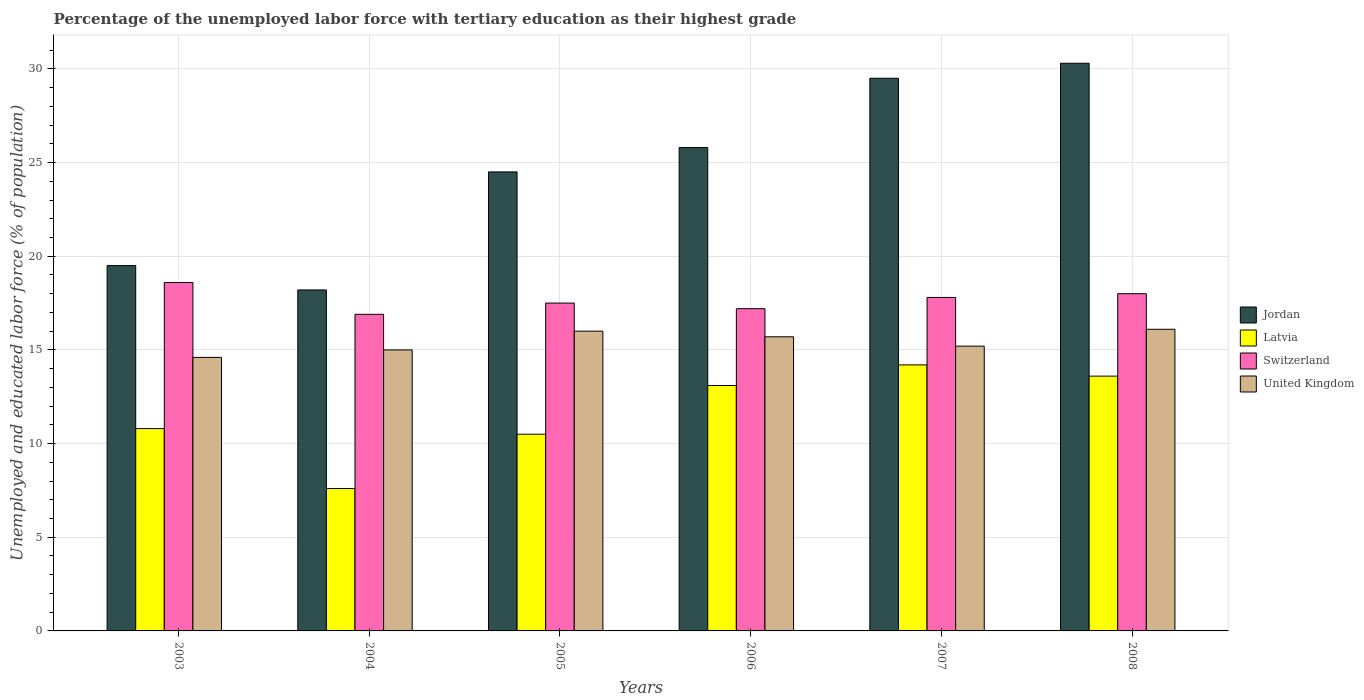How many groups of bars are there?
Offer a very short reply. 6. Are the number of bars per tick equal to the number of legend labels?
Your answer should be very brief. Yes. Are the number of bars on each tick of the X-axis equal?
Ensure brevity in your answer.  Yes. What is the percentage of the unemployed labor force with tertiary education in United Kingdom in 2006?
Your answer should be very brief. 15.7. Across all years, what is the maximum percentage of the unemployed labor force with tertiary education in Latvia?
Provide a short and direct response. 14.2. Across all years, what is the minimum percentage of the unemployed labor force with tertiary education in Switzerland?
Ensure brevity in your answer.  16.9. What is the total percentage of the unemployed labor force with tertiary education in Latvia in the graph?
Offer a terse response. 69.8. What is the difference between the percentage of the unemployed labor force with tertiary education in United Kingdom in 2005 and the percentage of the unemployed labor force with tertiary education in Jordan in 2003?
Provide a short and direct response. -3.5. What is the average percentage of the unemployed labor force with tertiary education in Switzerland per year?
Give a very brief answer. 17.67. In the year 2003, what is the difference between the percentage of the unemployed labor force with tertiary education in United Kingdom and percentage of the unemployed labor force with tertiary education in Jordan?
Your answer should be very brief. -4.9. What is the ratio of the percentage of the unemployed labor force with tertiary education in Latvia in 2003 to that in 2007?
Provide a short and direct response. 0.76. Is the difference between the percentage of the unemployed labor force with tertiary education in United Kingdom in 2004 and 2006 greater than the difference between the percentage of the unemployed labor force with tertiary education in Jordan in 2004 and 2006?
Your answer should be compact. Yes. What is the difference between the highest and the second highest percentage of the unemployed labor force with tertiary education in Jordan?
Your response must be concise. 0.8. What is the difference between the highest and the lowest percentage of the unemployed labor force with tertiary education in Switzerland?
Give a very brief answer. 1.7. Is it the case that in every year, the sum of the percentage of the unemployed labor force with tertiary education in Jordan and percentage of the unemployed labor force with tertiary education in Latvia is greater than the sum of percentage of the unemployed labor force with tertiary education in United Kingdom and percentage of the unemployed labor force with tertiary education in Switzerland?
Give a very brief answer. No. What does the 1st bar from the right in 2007 represents?
Make the answer very short. United Kingdom. How many bars are there?
Keep it short and to the point. 24. Are all the bars in the graph horizontal?
Offer a terse response. No. Does the graph contain grids?
Provide a short and direct response. Yes. What is the title of the graph?
Provide a short and direct response. Percentage of the unemployed labor force with tertiary education as their highest grade. What is the label or title of the Y-axis?
Give a very brief answer. Unemployed and educated labor force (% of population). What is the Unemployed and educated labor force (% of population) of Latvia in 2003?
Ensure brevity in your answer.  10.8. What is the Unemployed and educated labor force (% of population) in Switzerland in 2003?
Give a very brief answer. 18.6. What is the Unemployed and educated labor force (% of population) of United Kingdom in 2003?
Offer a terse response. 14.6. What is the Unemployed and educated labor force (% of population) in Jordan in 2004?
Provide a short and direct response. 18.2. What is the Unemployed and educated labor force (% of population) of Latvia in 2004?
Offer a terse response. 7.6. What is the Unemployed and educated labor force (% of population) of Switzerland in 2004?
Your response must be concise. 16.9. What is the Unemployed and educated labor force (% of population) in Jordan in 2005?
Keep it short and to the point. 24.5. What is the Unemployed and educated labor force (% of population) in United Kingdom in 2005?
Your answer should be very brief. 16. What is the Unemployed and educated labor force (% of population) of Jordan in 2006?
Provide a succinct answer. 25.8. What is the Unemployed and educated labor force (% of population) of Latvia in 2006?
Your response must be concise. 13.1. What is the Unemployed and educated labor force (% of population) in Switzerland in 2006?
Keep it short and to the point. 17.2. What is the Unemployed and educated labor force (% of population) of United Kingdom in 2006?
Keep it short and to the point. 15.7. What is the Unemployed and educated labor force (% of population) in Jordan in 2007?
Offer a very short reply. 29.5. What is the Unemployed and educated labor force (% of population) in Latvia in 2007?
Give a very brief answer. 14.2. What is the Unemployed and educated labor force (% of population) of Switzerland in 2007?
Keep it short and to the point. 17.8. What is the Unemployed and educated labor force (% of population) of United Kingdom in 2007?
Make the answer very short. 15.2. What is the Unemployed and educated labor force (% of population) of Jordan in 2008?
Ensure brevity in your answer.  30.3. What is the Unemployed and educated labor force (% of population) of Latvia in 2008?
Ensure brevity in your answer.  13.6. What is the Unemployed and educated labor force (% of population) of Switzerland in 2008?
Keep it short and to the point. 18. What is the Unemployed and educated labor force (% of population) in United Kingdom in 2008?
Your response must be concise. 16.1. Across all years, what is the maximum Unemployed and educated labor force (% of population) of Jordan?
Provide a short and direct response. 30.3. Across all years, what is the maximum Unemployed and educated labor force (% of population) in Latvia?
Provide a short and direct response. 14.2. Across all years, what is the maximum Unemployed and educated labor force (% of population) of Switzerland?
Keep it short and to the point. 18.6. Across all years, what is the maximum Unemployed and educated labor force (% of population) of United Kingdom?
Offer a terse response. 16.1. Across all years, what is the minimum Unemployed and educated labor force (% of population) in Jordan?
Make the answer very short. 18.2. Across all years, what is the minimum Unemployed and educated labor force (% of population) of Latvia?
Offer a very short reply. 7.6. Across all years, what is the minimum Unemployed and educated labor force (% of population) of Switzerland?
Give a very brief answer. 16.9. Across all years, what is the minimum Unemployed and educated labor force (% of population) in United Kingdom?
Offer a very short reply. 14.6. What is the total Unemployed and educated labor force (% of population) of Jordan in the graph?
Make the answer very short. 147.8. What is the total Unemployed and educated labor force (% of population) of Latvia in the graph?
Provide a short and direct response. 69.8. What is the total Unemployed and educated labor force (% of population) of Switzerland in the graph?
Offer a very short reply. 106. What is the total Unemployed and educated labor force (% of population) in United Kingdom in the graph?
Keep it short and to the point. 92.6. What is the difference between the Unemployed and educated labor force (% of population) of Jordan in 2003 and that in 2004?
Ensure brevity in your answer.  1.3. What is the difference between the Unemployed and educated labor force (% of population) in Switzerland in 2003 and that in 2004?
Offer a very short reply. 1.7. What is the difference between the Unemployed and educated labor force (% of population) in United Kingdom in 2003 and that in 2004?
Ensure brevity in your answer.  -0.4. What is the difference between the Unemployed and educated labor force (% of population) in United Kingdom in 2003 and that in 2006?
Provide a succinct answer. -1.1. What is the difference between the Unemployed and educated labor force (% of population) of Latvia in 2003 and that in 2007?
Your answer should be compact. -3.4. What is the difference between the Unemployed and educated labor force (% of population) of Jordan in 2003 and that in 2008?
Your response must be concise. -10.8. What is the difference between the Unemployed and educated labor force (% of population) in Switzerland in 2003 and that in 2008?
Keep it short and to the point. 0.6. What is the difference between the Unemployed and educated labor force (% of population) in Jordan in 2004 and that in 2005?
Give a very brief answer. -6.3. What is the difference between the Unemployed and educated labor force (% of population) in United Kingdom in 2004 and that in 2005?
Your response must be concise. -1. What is the difference between the Unemployed and educated labor force (% of population) in Latvia in 2004 and that in 2006?
Make the answer very short. -5.5. What is the difference between the Unemployed and educated labor force (% of population) in Jordan in 2004 and that in 2007?
Provide a succinct answer. -11.3. What is the difference between the Unemployed and educated labor force (% of population) in Latvia in 2004 and that in 2007?
Give a very brief answer. -6.6. What is the difference between the Unemployed and educated labor force (% of population) in Switzerland in 2004 and that in 2007?
Provide a succinct answer. -0.9. What is the difference between the Unemployed and educated labor force (% of population) of Latvia in 2004 and that in 2008?
Make the answer very short. -6. What is the difference between the Unemployed and educated labor force (% of population) in Switzerland in 2005 and that in 2006?
Give a very brief answer. 0.3. What is the difference between the Unemployed and educated labor force (% of population) of Jordan in 2005 and that in 2007?
Your answer should be very brief. -5. What is the difference between the Unemployed and educated labor force (% of population) in United Kingdom in 2005 and that in 2007?
Your answer should be compact. 0.8. What is the difference between the Unemployed and educated labor force (% of population) in Jordan in 2005 and that in 2008?
Provide a short and direct response. -5.8. What is the difference between the Unemployed and educated labor force (% of population) of Switzerland in 2005 and that in 2008?
Offer a very short reply. -0.5. What is the difference between the Unemployed and educated labor force (% of population) of Jordan in 2006 and that in 2007?
Your answer should be compact. -3.7. What is the difference between the Unemployed and educated labor force (% of population) in Latvia in 2006 and that in 2007?
Offer a terse response. -1.1. What is the difference between the Unemployed and educated labor force (% of population) in Switzerland in 2006 and that in 2007?
Offer a terse response. -0.6. What is the difference between the Unemployed and educated labor force (% of population) of United Kingdom in 2006 and that in 2007?
Provide a short and direct response. 0.5. What is the difference between the Unemployed and educated labor force (% of population) in Jordan in 2006 and that in 2008?
Offer a terse response. -4.5. What is the difference between the Unemployed and educated labor force (% of population) in United Kingdom in 2006 and that in 2008?
Give a very brief answer. -0.4. What is the difference between the Unemployed and educated labor force (% of population) in Latvia in 2007 and that in 2008?
Offer a terse response. 0.6. What is the difference between the Unemployed and educated labor force (% of population) in Switzerland in 2007 and that in 2008?
Make the answer very short. -0.2. What is the difference between the Unemployed and educated labor force (% of population) in Latvia in 2003 and the Unemployed and educated labor force (% of population) in Switzerland in 2004?
Keep it short and to the point. -6.1. What is the difference between the Unemployed and educated labor force (% of population) in Switzerland in 2003 and the Unemployed and educated labor force (% of population) in United Kingdom in 2004?
Offer a terse response. 3.6. What is the difference between the Unemployed and educated labor force (% of population) in Jordan in 2003 and the Unemployed and educated labor force (% of population) in Latvia in 2005?
Your answer should be compact. 9. What is the difference between the Unemployed and educated labor force (% of population) of Jordan in 2003 and the Unemployed and educated labor force (% of population) of Switzerland in 2005?
Your answer should be very brief. 2. What is the difference between the Unemployed and educated labor force (% of population) of Latvia in 2003 and the Unemployed and educated labor force (% of population) of Switzerland in 2005?
Provide a short and direct response. -6.7. What is the difference between the Unemployed and educated labor force (% of population) of Jordan in 2003 and the Unemployed and educated labor force (% of population) of Latvia in 2006?
Your response must be concise. 6.4. What is the difference between the Unemployed and educated labor force (% of population) of Jordan in 2003 and the Unemployed and educated labor force (% of population) of Switzerland in 2006?
Give a very brief answer. 2.3. What is the difference between the Unemployed and educated labor force (% of population) in Switzerland in 2003 and the Unemployed and educated labor force (% of population) in United Kingdom in 2006?
Offer a terse response. 2.9. What is the difference between the Unemployed and educated labor force (% of population) in Jordan in 2003 and the Unemployed and educated labor force (% of population) in Switzerland in 2007?
Your answer should be very brief. 1.7. What is the difference between the Unemployed and educated labor force (% of population) of Latvia in 2003 and the Unemployed and educated labor force (% of population) of Switzerland in 2007?
Your answer should be very brief. -7. What is the difference between the Unemployed and educated labor force (% of population) in Latvia in 2003 and the Unemployed and educated labor force (% of population) in United Kingdom in 2007?
Provide a short and direct response. -4.4. What is the difference between the Unemployed and educated labor force (% of population) in Switzerland in 2003 and the Unemployed and educated labor force (% of population) in United Kingdom in 2007?
Make the answer very short. 3.4. What is the difference between the Unemployed and educated labor force (% of population) of Jordan in 2003 and the Unemployed and educated labor force (% of population) of United Kingdom in 2008?
Ensure brevity in your answer.  3.4. What is the difference between the Unemployed and educated labor force (% of population) in Switzerland in 2003 and the Unemployed and educated labor force (% of population) in United Kingdom in 2008?
Offer a terse response. 2.5. What is the difference between the Unemployed and educated labor force (% of population) of Jordan in 2004 and the Unemployed and educated labor force (% of population) of Latvia in 2005?
Provide a short and direct response. 7.7. What is the difference between the Unemployed and educated labor force (% of population) in Jordan in 2004 and the Unemployed and educated labor force (% of population) in Switzerland in 2005?
Provide a short and direct response. 0.7. What is the difference between the Unemployed and educated labor force (% of population) in Latvia in 2004 and the Unemployed and educated labor force (% of population) in Switzerland in 2005?
Offer a terse response. -9.9. What is the difference between the Unemployed and educated labor force (% of population) of Jordan in 2004 and the Unemployed and educated labor force (% of population) of Latvia in 2006?
Your response must be concise. 5.1. What is the difference between the Unemployed and educated labor force (% of population) of Jordan in 2004 and the Unemployed and educated labor force (% of population) of Switzerland in 2006?
Offer a terse response. 1. What is the difference between the Unemployed and educated labor force (% of population) in Jordan in 2004 and the Unemployed and educated labor force (% of population) in United Kingdom in 2006?
Make the answer very short. 2.5. What is the difference between the Unemployed and educated labor force (% of population) in Latvia in 2004 and the Unemployed and educated labor force (% of population) in Switzerland in 2006?
Your response must be concise. -9.6. What is the difference between the Unemployed and educated labor force (% of population) of Jordan in 2004 and the Unemployed and educated labor force (% of population) of Latvia in 2007?
Offer a very short reply. 4. What is the difference between the Unemployed and educated labor force (% of population) in Jordan in 2004 and the Unemployed and educated labor force (% of population) in Switzerland in 2007?
Keep it short and to the point. 0.4. What is the difference between the Unemployed and educated labor force (% of population) of Jordan in 2004 and the Unemployed and educated labor force (% of population) of United Kingdom in 2007?
Provide a short and direct response. 3. What is the difference between the Unemployed and educated labor force (% of population) in Latvia in 2004 and the Unemployed and educated labor force (% of population) in Switzerland in 2007?
Your answer should be very brief. -10.2. What is the difference between the Unemployed and educated labor force (% of population) of Jordan in 2004 and the Unemployed and educated labor force (% of population) of Latvia in 2008?
Make the answer very short. 4.6. What is the difference between the Unemployed and educated labor force (% of population) in Jordan in 2004 and the Unemployed and educated labor force (% of population) in United Kingdom in 2008?
Your response must be concise. 2.1. What is the difference between the Unemployed and educated labor force (% of population) in Latvia in 2004 and the Unemployed and educated labor force (% of population) in Switzerland in 2008?
Provide a succinct answer. -10.4. What is the difference between the Unemployed and educated labor force (% of population) in Latvia in 2004 and the Unemployed and educated labor force (% of population) in United Kingdom in 2008?
Your answer should be very brief. -8.5. What is the difference between the Unemployed and educated labor force (% of population) of Switzerland in 2004 and the Unemployed and educated labor force (% of population) of United Kingdom in 2008?
Offer a terse response. 0.8. What is the difference between the Unemployed and educated labor force (% of population) of Jordan in 2005 and the Unemployed and educated labor force (% of population) of Latvia in 2006?
Offer a very short reply. 11.4. What is the difference between the Unemployed and educated labor force (% of population) in Jordan in 2005 and the Unemployed and educated labor force (% of population) in United Kingdom in 2006?
Your response must be concise. 8.8. What is the difference between the Unemployed and educated labor force (% of population) in Latvia in 2005 and the Unemployed and educated labor force (% of population) in United Kingdom in 2006?
Offer a terse response. -5.2. What is the difference between the Unemployed and educated labor force (% of population) in Switzerland in 2005 and the Unemployed and educated labor force (% of population) in United Kingdom in 2006?
Offer a very short reply. 1.8. What is the difference between the Unemployed and educated labor force (% of population) of Jordan in 2005 and the Unemployed and educated labor force (% of population) of United Kingdom in 2007?
Your answer should be very brief. 9.3. What is the difference between the Unemployed and educated labor force (% of population) of Switzerland in 2005 and the Unemployed and educated labor force (% of population) of United Kingdom in 2007?
Your answer should be compact. 2.3. What is the difference between the Unemployed and educated labor force (% of population) in Jordan in 2005 and the Unemployed and educated labor force (% of population) in Switzerland in 2008?
Your answer should be compact. 6.5. What is the difference between the Unemployed and educated labor force (% of population) of Latvia in 2005 and the Unemployed and educated labor force (% of population) of United Kingdom in 2008?
Your answer should be compact. -5.6. What is the difference between the Unemployed and educated labor force (% of population) of Switzerland in 2005 and the Unemployed and educated labor force (% of population) of United Kingdom in 2008?
Give a very brief answer. 1.4. What is the difference between the Unemployed and educated labor force (% of population) in Jordan in 2006 and the Unemployed and educated labor force (% of population) in Latvia in 2007?
Your answer should be compact. 11.6. What is the difference between the Unemployed and educated labor force (% of population) of Jordan in 2006 and the Unemployed and educated labor force (% of population) of Switzerland in 2007?
Give a very brief answer. 8. What is the difference between the Unemployed and educated labor force (% of population) in Jordan in 2006 and the Unemployed and educated labor force (% of population) in United Kingdom in 2007?
Offer a very short reply. 10.6. What is the difference between the Unemployed and educated labor force (% of population) in Latvia in 2006 and the Unemployed and educated labor force (% of population) in Switzerland in 2007?
Keep it short and to the point. -4.7. What is the difference between the Unemployed and educated labor force (% of population) of Switzerland in 2006 and the Unemployed and educated labor force (% of population) of United Kingdom in 2007?
Offer a very short reply. 2. What is the difference between the Unemployed and educated labor force (% of population) of Jordan in 2006 and the Unemployed and educated labor force (% of population) of Latvia in 2008?
Give a very brief answer. 12.2. What is the difference between the Unemployed and educated labor force (% of population) of Jordan in 2006 and the Unemployed and educated labor force (% of population) of Switzerland in 2008?
Keep it short and to the point. 7.8. What is the difference between the Unemployed and educated labor force (% of population) in Jordan in 2006 and the Unemployed and educated labor force (% of population) in United Kingdom in 2008?
Your answer should be very brief. 9.7. What is the difference between the Unemployed and educated labor force (% of population) in Jordan in 2007 and the Unemployed and educated labor force (% of population) in Latvia in 2008?
Keep it short and to the point. 15.9. What is the difference between the Unemployed and educated labor force (% of population) in Latvia in 2007 and the Unemployed and educated labor force (% of population) in United Kingdom in 2008?
Offer a terse response. -1.9. What is the difference between the Unemployed and educated labor force (% of population) of Switzerland in 2007 and the Unemployed and educated labor force (% of population) of United Kingdom in 2008?
Provide a short and direct response. 1.7. What is the average Unemployed and educated labor force (% of population) in Jordan per year?
Keep it short and to the point. 24.63. What is the average Unemployed and educated labor force (% of population) in Latvia per year?
Your answer should be compact. 11.63. What is the average Unemployed and educated labor force (% of population) of Switzerland per year?
Ensure brevity in your answer.  17.67. What is the average Unemployed and educated labor force (% of population) in United Kingdom per year?
Your response must be concise. 15.43. In the year 2003, what is the difference between the Unemployed and educated labor force (% of population) in Jordan and Unemployed and educated labor force (% of population) in Latvia?
Offer a very short reply. 8.7. In the year 2003, what is the difference between the Unemployed and educated labor force (% of population) in Jordan and Unemployed and educated labor force (% of population) in United Kingdom?
Offer a terse response. 4.9. In the year 2003, what is the difference between the Unemployed and educated labor force (% of population) of Latvia and Unemployed and educated labor force (% of population) of Switzerland?
Your response must be concise. -7.8. In the year 2003, what is the difference between the Unemployed and educated labor force (% of population) of Switzerland and Unemployed and educated labor force (% of population) of United Kingdom?
Your answer should be very brief. 4. In the year 2004, what is the difference between the Unemployed and educated labor force (% of population) in Latvia and Unemployed and educated labor force (% of population) in Switzerland?
Ensure brevity in your answer.  -9.3. In the year 2004, what is the difference between the Unemployed and educated labor force (% of population) in Switzerland and Unemployed and educated labor force (% of population) in United Kingdom?
Keep it short and to the point. 1.9. In the year 2005, what is the difference between the Unemployed and educated labor force (% of population) in Latvia and Unemployed and educated labor force (% of population) in Switzerland?
Keep it short and to the point. -7. In the year 2005, what is the difference between the Unemployed and educated labor force (% of population) of Latvia and Unemployed and educated labor force (% of population) of United Kingdom?
Provide a short and direct response. -5.5. In the year 2005, what is the difference between the Unemployed and educated labor force (% of population) of Switzerland and Unemployed and educated labor force (% of population) of United Kingdom?
Ensure brevity in your answer.  1.5. In the year 2006, what is the difference between the Unemployed and educated labor force (% of population) of Jordan and Unemployed and educated labor force (% of population) of Latvia?
Your answer should be compact. 12.7. In the year 2006, what is the difference between the Unemployed and educated labor force (% of population) in Jordan and Unemployed and educated labor force (% of population) in Switzerland?
Provide a short and direct response. 8.6. In the year 2006, what is the difference between the Unemployed and educated labor force (% of population) in Jordan and Unemployed and educated labor force (% of population) in United Kingdom?
Your answer should be very brief. 10.1. In the year 2006, what is the difference between the Unemployed and educated labor force (% of population) in Latvia and Unemployed and educated labor force (% of population) in Switzerland?
Ensure brevity in your answer.  -4.1. What is the ratio of the Unemployed and educated labor force (% of population) of Jordan in 2003 to that in 2004?
Provide a short and direct response. 1.07. What is the ratio of the Unemployed and educated labor force (% of population) of Latvia in 2003 to that in 2004?
Ensure brevity in your answer.  1.42. What is the ratio of the Unemployed and educated labor force (% of population) of Switzerland in 2003 to that in 2004?
Offer a very short reply. 1.1. What is the ratio of the Unemployed and educated labor force (% of population) of United Kingdom in 2003 to that in 2004?
Your answer should be compact. 0.97. What is the ratio of the Unemployed and educated labor force (% of population) of Jordan in 2003 to that in 2005?
Provide a short and direct response. 0.8. What is the ratio of the Unemployed and educated labor force (% of population) in Latvia in 2003 to that in 2005?
Your answer should be very brief. 1.03. What is the ratio of the Unemployed and educated labor force (% of population) in Switzerland in 2003 to that in 2005?
Your response must be concise. 1.06. What is the ratio of the Unemployed and educated labor force (% of population) in United Kingdom in 2003 to that in 2005?
Your response must be concise. 0.91. What is the ratio of the Unemployed and educated labor force (% of population) in Jordan in 2003 to that in 2006?
Your answer should be very brief. 0.76. What is the ratio of the Unemployed and educated labor force (% of population) in Latvia in 2003 to that in 2006?
Your answer should be very brief. 0.82. What is the ratio of the Unemployed and educated labor force (% of population) of Switzerland in 2003 to that in 2006?
Keep it short and to the point. 1.08. What is the ratio of the Unemployed and educated labor force (% of population) of United Kingdom in 2003 to that in 2006?
Your response must be concise. 0.93. What is the ratio of the Unemployed and educated labor force (% of population) in Jordan in 2003 to that in 2007?
Make the answer very short. 0.66. What is the ratio of the Unemployed and educated labor force (% of population) of Latvia in 2003 to that in 2007?
Provide a succinct answer. 0.76. What is the ratio of the Unemployed and educated labor force (% of population) in Switzerland in 2003 to that in 2007?
Keep it short and to the point. 1.04. What is the ratio of the Unemployed and educated labor force (% of population) of United Kingdom in 2003 to that in 2007?
Make the answer very short. 0.96. What is the ratio of the Unemployed and educated labor force (% of population) in Jordan in 2003 to that in 2008?
Offer a terse response. 0.64. What is the ratio of the Unemployed and educated labor force (% of population) in Latvia in 2003 to that in 2008?
Provide a short and direct response. 0.79. What is the ratio of the Unemployed and educated labor force (% of population) in United Kingdom in 2003 to that in 2008?
Offer a terse response. 0.91. What is the ratio of the Unemployed and educated labor force (% of population) in Jordan in 2004 to that in 2005?
Your response must be concise. 0.74. What is the ratio of the Unemployed and educated labor force (% of population) of Latvia in 2004 to that in 2005?
Your answer should be compact. 0.72. What is the ratio of the Unemployed and educated labor force (% of population) in Switzerland in 2004 to that in 2005?
Your answer should be very brief. 0.97. What is the ratio of the Unemployed and educated labor force (% of population) in United Kingdom in 2004 to that in 2005?
Provide a succinct answer. 0.94. What is the ratio of the Unemployed and educated labor force (% of population) of Jordan in 2004 to that in 2006?
Your response must be concise. 0.71. What is the ratio of the Unemployed and educated labor force (% of population) of Latvia in 2004 to that in 2006?
Provide a short and direct response. 0.58. What is the ratio of the Unemployed and educated labor force (% of population) in Switzerland in 2004 to that in 2006?
Ensure brevity in your answer.  0.98. What is the ratio of the Unemployed and educated labor force (% of population) in United Kingdom in 2004 to that in 2006?
Your answer should be very brief. 0.96. What is the ratio of the Unemployed and educated labor force (% of population) in Jordan in 2004 to that in 2007?
Offer a terse response. 0.62. What is the ratio of the Unemployed and educated labor force (% of population) of Latvia in 2004 to that in 2007?
Provide a succinct answer. 0.54. What is the ratio of the Unemployed and educated labor force (% of population) in Switzerland in 2004 to that in 2007?
Provide a succinct answer. 0.95. What is the ratio of the Unemployed and educated labor force (% of population) of United Kingdom in 2004 to that in 2007?
Ensure brevity in your answer.  0.99. What is the ratio of the Unemployed and educated labor force (% of population) of Jordan in 2004 to that in 2008?
Your response must be concise. 0.6. What is the ratio of the Unemployed and educated labor force (% of population) in Latvia in 2004 to that in 2008?
Give a very brief answer. 0.56. What is the ratio of the Unemployed and educated labor force (% of population) of Switzerland in 2004 to that in 2008?
Keep it short and to the point. 0.94. What is the ratio of the Unemployed and educated labor force (% of population) of United Kingdom in 2004 to that in 2008?
Make the answer very short. 0.93. What is the ratio of the Unemployed and educated labor force (% of population) of Jordan in 2005 to that in 2006?
Your answer should be compact. 0.95. What is the ratio of the Unemployed and educated labor force (% of population) in Latvia in 2005 to that in 2006?
Keep it short and to the point. 0.8. What is the ratio of the Unemployed and educated labor force (% of population) in Switzerland in 2005 to that in 2006?
Provide a short and direct response. 1.02. What is the ratio of the Unemployed and educated labor force (% of population) of United Kingdom in 2005 to that in 2006?
Make the answer very short. 1.02. What is the ratio of the Unemployed and educated labor force (% of population) of Jordan in 2005 to that in 2007?
Your answer should be compact. 0.83. What is the ratio of the Unemployed and educated labor force (% of population) in Latvia in 2005 to that in 2007?
Make the answer very short. 0.74. What is the ratio of the Unemployed and educated labor force (% of population) of Switzerland in 2005 to that in 2007?
Provide a succinct answer. 0.98. What is the ratio of the Unemployed and educated labor force (% of population) of United Kingdom in 2005 to that in 2007?
Make the answer very short. 1.05. What is the ratio of the Unemployed and educated labor force (% of population) of Jordan in 2005 to that in 2008?
Keep it short and to the point. 0.81. What is the ratio of the Unemployed and educated labor force (% of population) in Latvia in 2005 to that in 2008?
Give a very brief answer. 0.77. What is the ratio of the Unemployed and educated labor force (% of population) in Switzerland in 2005 to that in 2008?
Make the answer very short. 0.97. What is the ratio of the Unemployed and educated labor force (% of population) of Jordan in 2006 to that in 2007?
Offer a very short reply. 0.87. What is the ratio of the Unemployed and educated labor force (% of population) in Latvia in 2006 to that in 2007?
Provide a short and direct response. 0.92. What is the ratio of the Unemployed and educated labor force (% of population) in Switzerland in 2006 to that in 2007?
Your answer should be compact. 0.97. What is the ratio of the Unemployed and educated labor force (% of population) of United Kingdom in 2006 to that in 2007?
Give a very brief answer. 1.03. What is the ratio of the Unemployed and educated labor force (% of population) of Jordan in 2006 to that in 2008?
Make the answer very short. 0.85. What is the ratio of the Unemployed and educated labor force (% of population) of Latvia in 2006 to that in 2008?
Offer a very short reply. 0.96. What is the ratio of the Unemployed and educated labor force (% of population) in Switzerland in 2006 to that in 2008?
Keep it short and to the point. 0.96. What is the ratio of the Unemployed and educated labor force (% of population) in United Kingdom in 2006 to that in 2008?
Your answer should be compact. 0.98. What is the ratio of the Unemployed and educated labor force (% of population) in Jordan in 2007 to that in 2008?
Your response must be concise. 0.97. What is the ratio of the Unemployed and educated labor force (% of population) in Latvia in 2007 to that in 2008?
Your answer should be very brief. 1.04. What is the ratio of the Unemployed and educated labor force (% of population) in Switzerland in 2007 to that in 2008?
Give a very brief answer. 0.99. What is the ratio of the Unemployed and educated labor force (% of population) of United Kingdom in 2007 to that in 2008?
Give a very brief answer. 0.94. What is the difference between the highest and the second highest Unemployed and educated labor force (% of population) of Jordan?
Your answer should be compact. 0.8. What is the difference between the highest and the lowest Unemployed and educated labor force (% of population) in Switzerland?
Keep it short and to the point. 1.7. 